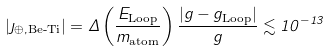<formula> <loc_0><loc_0><loc_500><loc_500>| \eta _ { \oplus , \text {Be-Ti} } | = \Delta \left ( \frac { E _ { \text {Loop} } } { m _ { \text {atom} } } \right ) \frac { | g - g _ { \text {Loop} } | } { g } \lesssim 1 0 ^ { - 1 3 }</formula> 